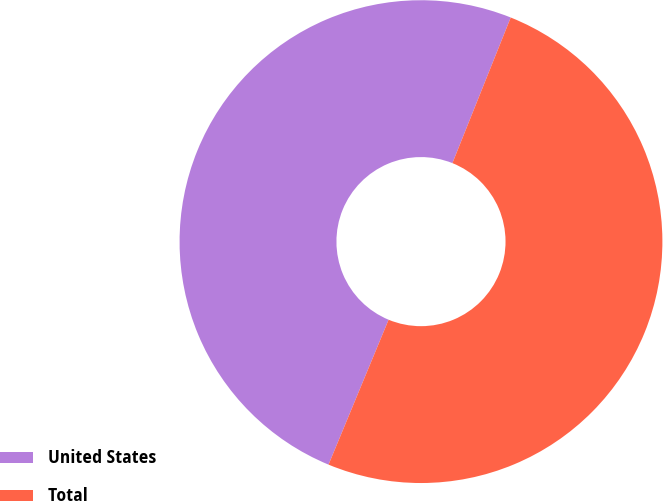Convert chart to OTSL. <chart><loc_0><loc_0><loc_500><loc_500><pie_chart><fcel>United States<fcel>Total<nl><fcel>49.81%<fcel>50.19%<nl></chart> 